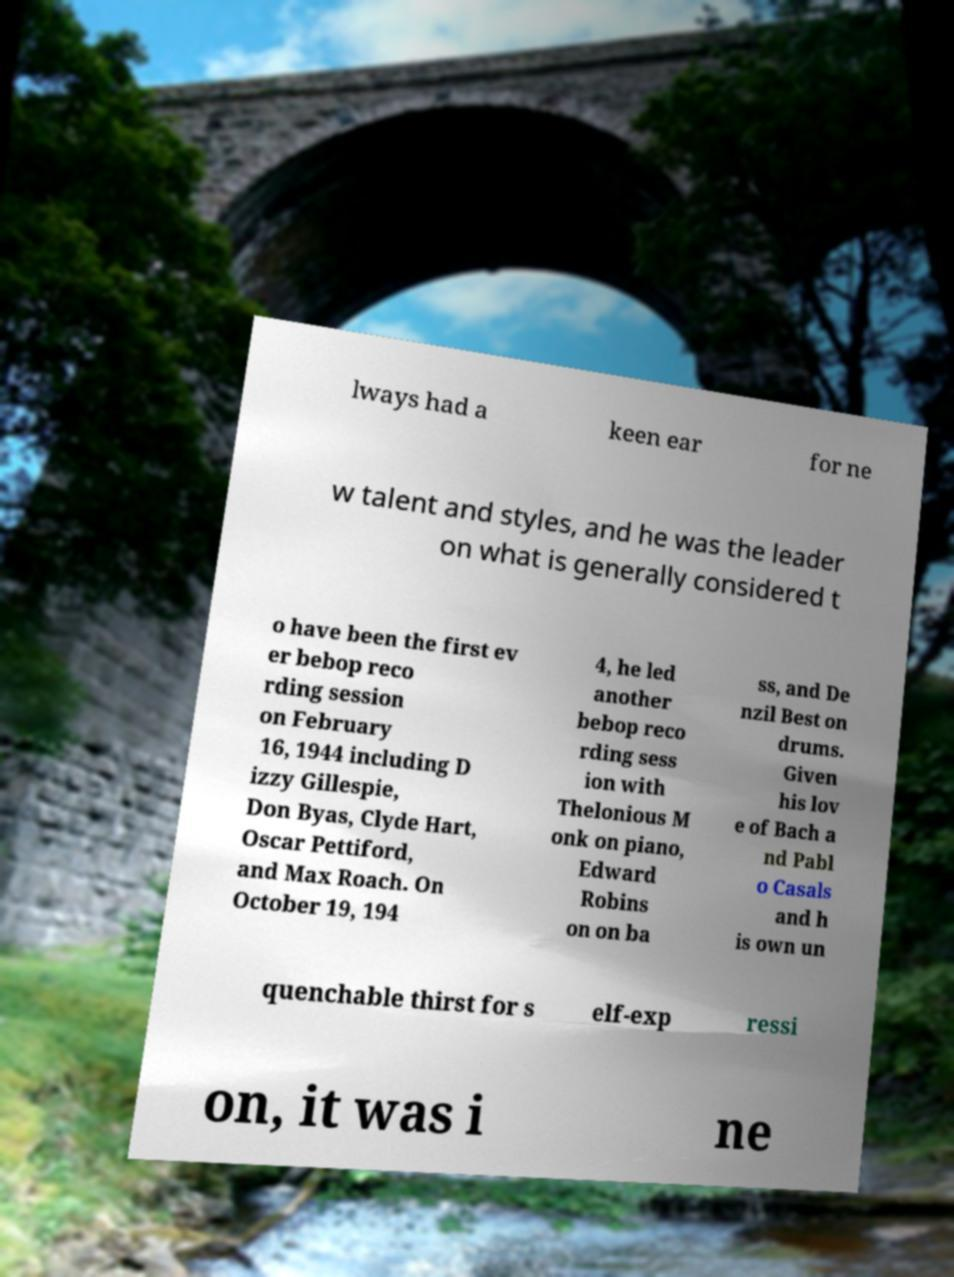I need the written content from this picture converted into text. Can you do that? lways had a keen ear for ne w talent and styles, and he was the leader on what is generally considered t o have been the first ev er bebop reco rding session on February 16, 1944 including D izzy Gillespie, Don Byas, Clyde Hart, Oscar Pettiford, and Max Roach. On October 19, 194 4, he led another bebop reco rding sess ion with Thelonious M onk on piano, Edward Robins on on ba ss, and De nzil Best on drums. Given his lov e of Bach a nd Pabl o Casals and h is own un quenchable thirst for s elf-exp ressi on, it was i ne 